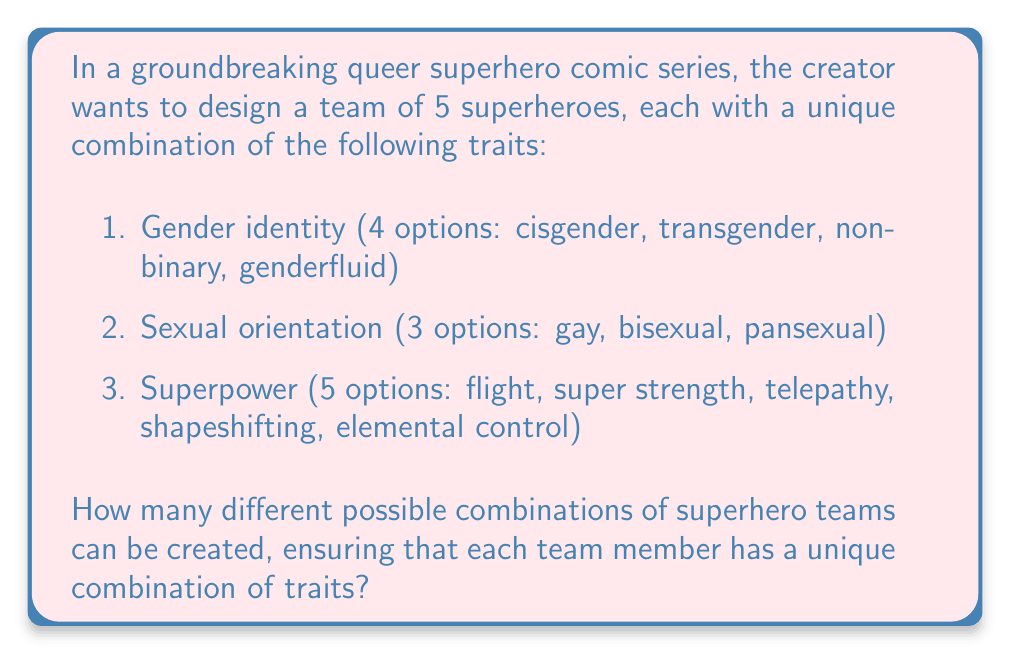Could you help me with this problem? To solve this problem, we'll use the multiplication principle and combinatorics. Let's break it down step by step:

1. First, we need to calculate the total number of possible unique characters:
   $4 \text{ (gender identities)} \times 3 \text{ (sexual orientations)} \times 5 \text{ (superpowers)} = 60$ unique characters

2. Now, we need to choose 5 characters out of these 60 unique characters. This is a combination problem, as the order doesn't matter (it's a team, not a lineup). We use the combination formula:

   $$\binom{60}{5} = \frac{60!}{5!(60-5)!} = \frac{60!}{5!55!}$$

3. Let's calculate this:
   
   $$\begin{align}
   \binom{60}{5} &= \frac{60 \times 59 \times 58 \times 57 \times 56}{5 \times 4 \times 3 \times 2 \times 1} \\
   &= \frac{623,376,000}{120} \\
   &= 5,194,800
   \end{align}$$

Therefore, there are 5,194,800 different possible combinations of superhero teams that can be created with unique trait combinations.
Answer: 5,194,800 possible team combinations 